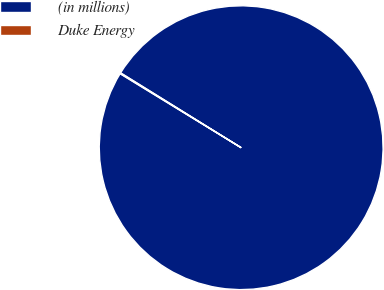<chart> <loc_0><loc_0><loc_500><loc_500><pie_chart><fcel>(in millions)<fcel>Duke Energy<nl><fcel>99.9%<fcel>0.1%<nl></chart> 